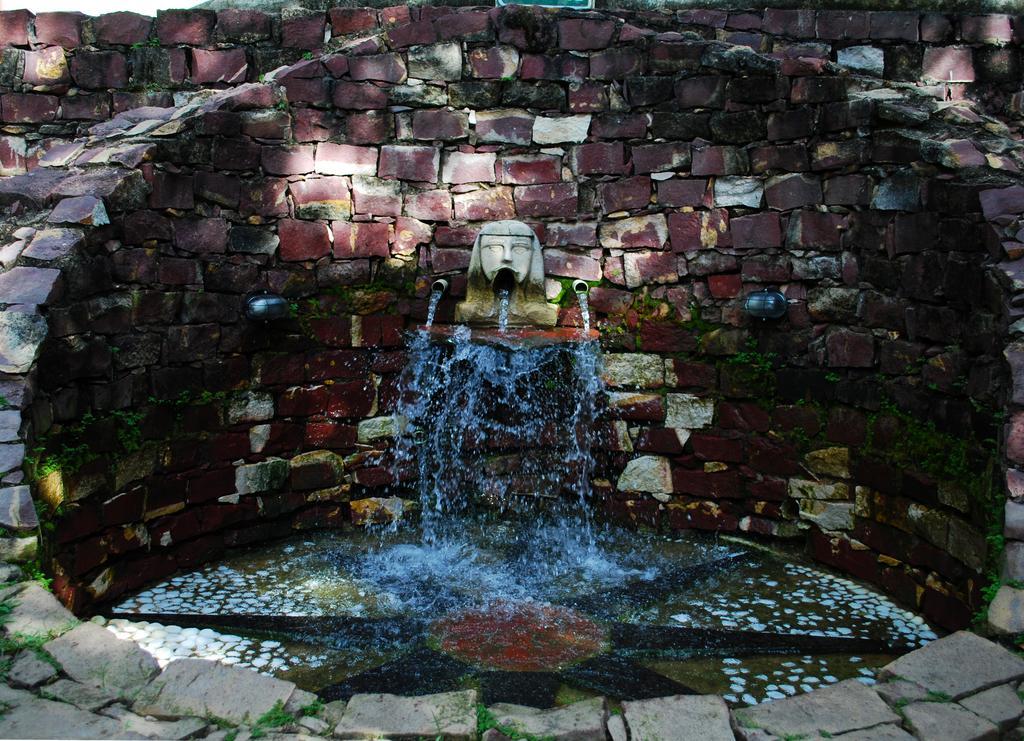Describe this image in one or two sentences. In this picture we can see water and few rocks, at the bottom of the image we can see grass. 